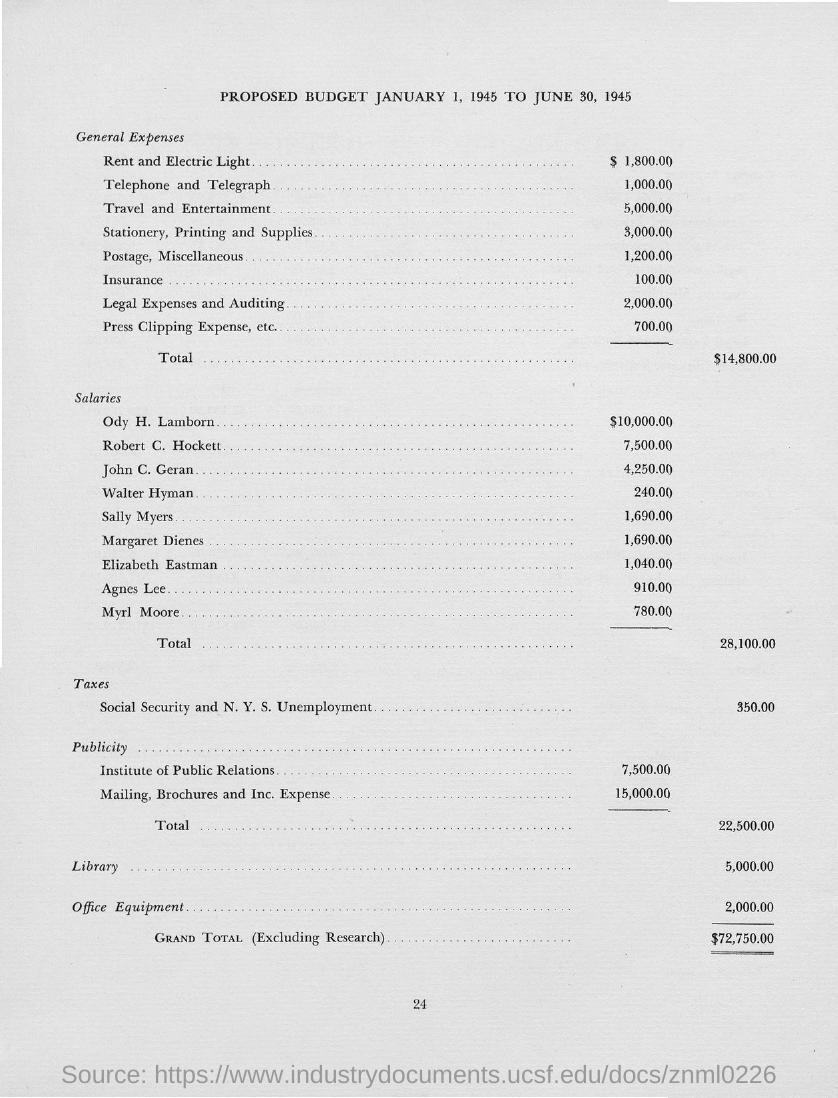What is the Page Number?
Your response must be concise. 24. 